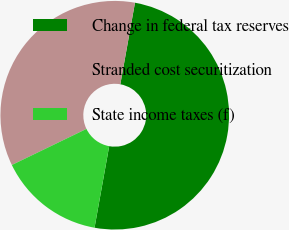Convert chart to OTSL. <chart><loc_0><loc_0><loc_500><loc_500><pie_chart><fcel>Change in federal tax reserves<fcel>Stranded cost securitization<fcel>State income taxes (f)<nl><fcel>50.0%<fcel>35.0%<fcel>15.0%<nl></chart> 